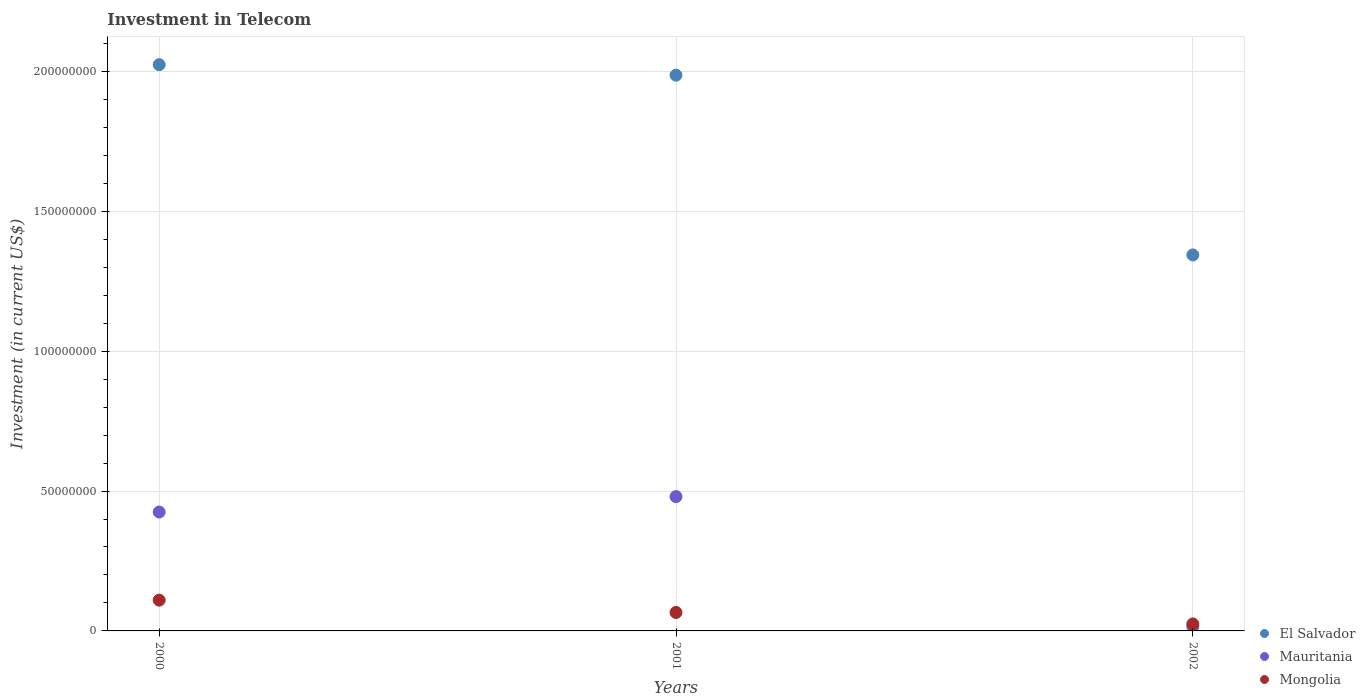How many different coloured dotlines are there?
Provide a short and direct response. 3. Is the number of dotlines equal to the number of legend labels?
Keep it short and to the point. Yes. What is the amount invested in telecom in Mauritania in 2001?
Your answer should be very brief. 4.80e+07. Across all years, what is the maximum amount invested in telecom in Mauritania?
Keep it short and to the point. 4.80e+07. Across all years, what is the minimum amount invested in telecom in Mongolia?
Your answer should be compact. 2.50e+06. In which year was the amount invested in telecom in El Salvador maximum?
Ensure brevity in your answer.  2000. In which year was the amount invested in telecom in Mongolia minimum?
Offer a very short reply. 2002. What is the total amount invested in telecom in El Salvador in the graph?
Your answer should be very brief. 5.35e+08. What is the difference between the amount invested in telecom in El Salvador in 2000 and that in 2002?
Offer a very short reply. 6.80e+07. What is the difference between the amount invested in telecom in Mauritania in 2002 and the amount invested in telecom in Mongolia in 2001?
Provide a succinct answer. -5.00e+06. What is the average amount invested in telecom in Mongolia per year?
Your answer should be compact. 6.70e+06. In the year 2002, what is the difference between the amount invested in telecom in El Salvador and amount invested in telecom in Mauritania?
Ensure brevity in your answer.  1.33e+08. In how many years, is the amount invested in telecom in Mauritania greater than 200000000 US$?
Keep it short and to the point. 0. What is the ratio of the amount invested in telecom in Mongolia in 2000 to that in 2001?
Offer a terse response. 1.67. Is the amount invested in telecom in Mauritania in 2001 less than that in 2002?
Give a very brief answer. No. What is the difference between the highest and the second highest amount invested in telecom in El Salvador?
Provide a short and direct response. 3.76e+06. What is the difference between the highest and the lowest amount invested in telecom in Mauritania?
Keep it short and to the point. 4.64e+07. Does the amount invested in telecom in Mongolia monotonically increase over the years?
Keep it short and to the point. No. How many dotlines are there?
Make the answer very short. 3. How many years are there in the graph?
Your response must be concise. 3. Are the values on the major ticks of Y-axis written in scientific E-notation?
Keep it short and to the point. No. Does the graph contain grids?
Give a very brief answer. Yes. Where does the legend appear in the graph?
Offer a very short reply. Bottom right. How are the legend labels stacked?
Provide a succinct answer. Vertical. What is the title of the graph?
Keep it short and to the point. Investment in Telecom. Does "United States" appear as one of the legend labels in the graph?
Ensure brevity in your answer.  No. What is the label or title of the Y-axis?
Offer a terse response. Investment (in current US$). What is the Investment (in current US$) of El Salvador in 2000?
Your answer should be very brief. 2.02e+08. What is the Investment (in current US$) in Mauritania in 2000?
Ensure brevity in your answer.  4.25e+07. What is the Investment (in current US$) in Mongolia in 2000?
Provide a succinct answer. 1.10e+07. What is the Investment (in current US$) of El Salvador in 2001?
Offer a very short reply. 1.99e+08. What is the Investment (in current US$) in Mauritania in 2001?
Offer a terse response. 4.80e+07. What is the Investment (in current US$) of Mongolia in 2001?
Offer a terse response. 6.60e+06. What is the Investment (in current US$) in El Salvador in 2002?
Offer a very short reply. 1.34e+08. What is the Investment (in current US$) in Mauritania in 2002?
Offer a terse response. 1.60e+06. What is the Investment (in current US$) of Mongolia in 2002?
Your response must be concise. 2.50e+06. Across all years, what is the maximum Investment (in current US$) in El Salvador?
Keep it short and to the point. 2.02e+08. Across all years, what is the maximum Investment (in current US$) of Mauritania?
Provide a short and direct response. 4.80e+07. Across all years, what is the maximum Investment (in current US$) in Mongolia?
Offer a very short reply. 1.10e+07. Across all years, what is the minimum Investment (in current US$) in El Salvador?
Make the answer very short. 1.34e+08. Across all years, what is the minimum Investment (in current US$) of Mauritania?
Your answer should be compact. 1.60e+06. Across all years, what is the minimum Investment (in current US$) of Mongolia?
Keep it short and to the point. 2.50e+06. What is the total Investment (in current US$) of El Salvador in the graph?
Your answer should be compact. 5.35e+08. What is the total Investment (in current US$) in Mauritania in the graph?
Give a very brief answer. 9.21e+07. What is the total Investment (in current US$) in Mongolia in the graph?
Offer a very short reply. 2.01e+07. What is the difference between the Investment (in current US$) of El Salvador in 2000 and that in 2001?
Your answer should be compact. 3.76e+06. What is the difference between the Investment (in current US$) in Mauritania in 2000 and that in 2001?
Your answer should be compact. -5.50e+06. What is the difference between the Investment (in current US$) in Mongolia in 2000 and that in 2001?
Offer a very short reply. 4.40e+06. What is the difference between the Investment (in current US$) of El Salvador in 2000 and that in 2002?
Offer a terse response. 6.80e+07. What is the difference between the Investment (in current US$) in Mauritania in 2000 and that in 2002?
Offer a terse response. 4.09e+07. What is the difference between the Investment (in current US$) in Mongolia in 2000 and that in 2002?
Ensure brevity in your answer.  8.50e+06. What is the difference between the Investment (in current US$) of El Salvador in 2001 and that in 2002?
Provide a succinct answer. 6.42e+07. What is the difference between the Investment (in current US$) of Mauritania in 2001 and that in 2002?
Make the answer very short. 4.64e+07. What is the difference between the Investment (in current US$) of Mongolia in 2001 and that in 2002?
Offer a terse response. 4.10e+06. What is the difference between the Investment (in current US$) of El Salvador in 2000 and the Investment (in current US$) of Mauritania in 2001?
Make the answer very short. 1.54e+08. What is the difference between the Investment (in current US$) in El Salvador in 2000 and the Investment (in current US$) in Mongolia in 2001?
Provide a short and direct response. 1.96e+08. What is the difference between the Investment (in current US$) of Mauritania in 2000 and the Investment (in current US$) of Mongolia in 2001?
Provide a succinct answer. 3.59e+07. What is the difference between the Investment (in current US$) in El Salvador in 2000 and the Investment (in current US$) in Mauritania in 2002?
Your response must be concise. 2.01e+08. What is the difference between the Investment (in current US$) of El Salvador in 2000 and the Investment (in current US$) of Mongolia in 2002?
Offer a terse response. 2.00e+08. What is the difference between the Investment (in current US$) of Mauritania in 2000 and the Investment (in current US$) of Mongolia in 2002?
Make the answer very short. 4.00e+07. What is the difference between the Investment (in current US$) in El Salvador in 2001 and the Investment (in current US$) in Mauritania in 2002?
Offer a terse response. 1.97e+08. What is the difference between the Investment (in current US$) of El Salvador in 2001 and the Investment (in current US$) of Mongolia in 2002?
Offer a very short reply. 1.96e+08. What is the difference between the Investment (in current US$) of Mauritania in 2001 and the Investment (in current US$) of Mongolia in 2002?
Offer a terse response. 4.55e+07. What is the average Investment (in current US$) in El Salvador per year?
Give a very brief answer. 1.78e+08. What is the average Investment (in current US$) of Mauritania per year?
Offer a very short reply. 3.07e+07. What is the average Investment (in current US$) of Mongolia per year?
Make the answer very short. 6.70e+06. In the year 2000, what is the difference between the Investment (in current US$) in El Salvador and Investment (in current US$) in Mauritania?
Make the answer very short. 1.60e+08. In the year 2000, what is the difference between the Investment (in current US$) of El Salvador and Investment (in current US$) of Mongolia?
Offer a terse response. 1.91e+08. In the year 2000, what is the difference between the Investment (in current US$) of Mauritania and Investment (in current US$) of Mongolia?
Your answer should be very brief. 3.15e+07. In the year 2001, what is the difference between the Investment (in current US$) in El Salvador and Investment (in current US$) in Mauritania?
Make the answer very short. 1.51e+08. In the year 2001, what is the difference between the Investment (in current US$) of El Salvador and Investment (in current US$) of Mongolia?
Give a very brief answer. 1.92e+08. In the year 2001, what is the difference between the Investment (in current US$) of Mauritania and Investment (in current US$) of Mongolia?
Provide a short and direct response. 4.14e+07. In the year 2002, what is the difference between the Investment (in current US$) in El Salvador and Investment (in current US$) in Mauritania?
Make the answer very short. 1.33e+08. In the year 2002, what is the difference between the Investment (in current US$) of El Salvador and Investment (in current US$) of Mongolia?
Offer a very short reply. 1.32e+08. In the year 2002, what is the difference between the Investment (in current US$) in Mauritania and Investment (in current US$) in Mongolia?
Provide a succinct answer. -9.00e+05. What is the ratio of the Investment (in current US$) in El Salvador in 2000 to that in 2001?
Your answer should be very brief. 1.02. What is the ratio of the Investment (in current US$) of Mauritania in 2000 to that in 2001?
Ensure brevity in your answer.  0.89. What is the ratio of the Investment (in current US$) of Mongolia in 2000 to that in 2001?
Your answer should be compact. 1.67. What is the ratio of the Investment (in current US$) of El Salvador in 2000 to that in 2002?
Ensure brevity in your answer.  1.51. What is the ratio of the Investment (in current US$) of Mauritania in 2000 to that in 2002?
Your answer should be compact. 26.56. What is the ratio of the Investment (in current US$) of Mongolia in 2000 to that in 2002?
Keep it short and to the point. 4.4. What is the ratio of the Investment (in current US$) of El Salvador in 2001 to that in 2002?
Give a very brief answer. 1.48. What is the ratio of the Investment (in current US$) of Mongolia in 2001 to that in 2002?
Offer a terse response. 2.64. What is the difference between the highest and the second highest Investment (in current US$) of El Salvador?
Give a very brief answer. 3.76e+06. What is the difference between the highest and the second highest Investment (in current US$) in Mauritania?
Your answer should be compact. 5.50e+06. What is the difference between the highest and the second highest Investment (in current US$) of Mongolia?
Your response must be concise. 4.40e+06. What is the difference between the highest and the lowest Investment (in current US$) in El Salvador?
Your response must be concise. 6.80e+07. What is the difference between the highest and the lowest Investment (in current US$) of Mauritania?
Provide a succinct answer. 4.64e+07. What is the difference between the highest and the lowest Investment (in current US$) in Mongolia?
Your answer should be compact. 8.50e+06. 